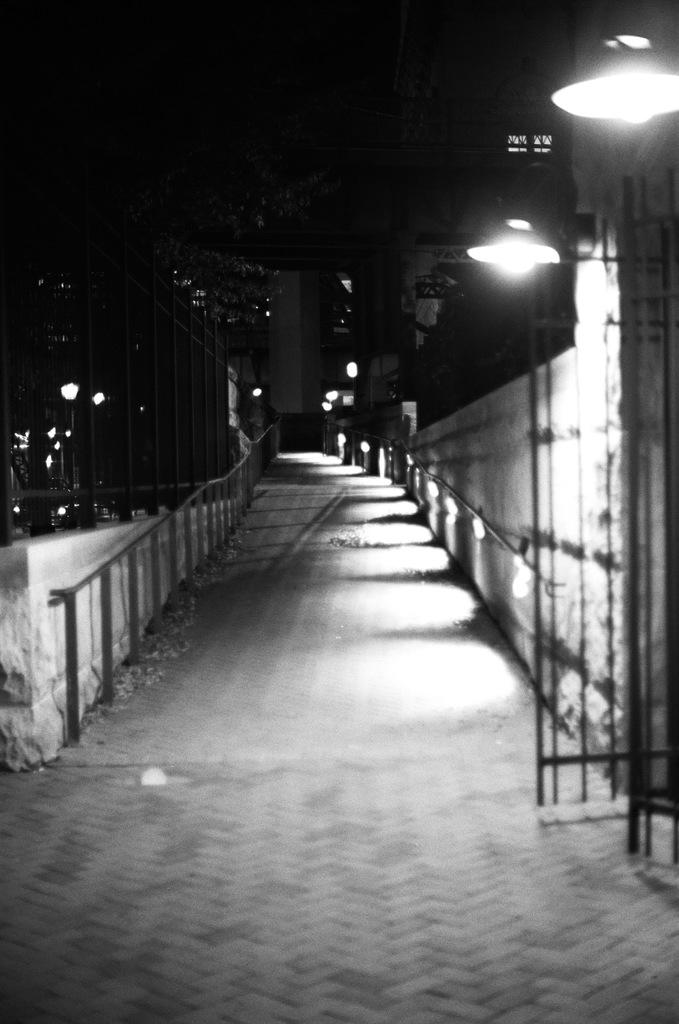What is the color scheme of the image? The image is black and white. What type of structures can be seen in the image? There are street lights, fencing, a wall, poles, and buildings in the image. What type of pathway is present in the image? There is a walkway in the image. What part of the natural environment is visible in the image? The sky is visible in the image. What type of veil can be seen covering the buildings in the image? There is no veil present in the image; the buildings are not covered. How many oranges are visible on the walkway in the image? There are no oranges present in the image; they are not visible on the walkway. 